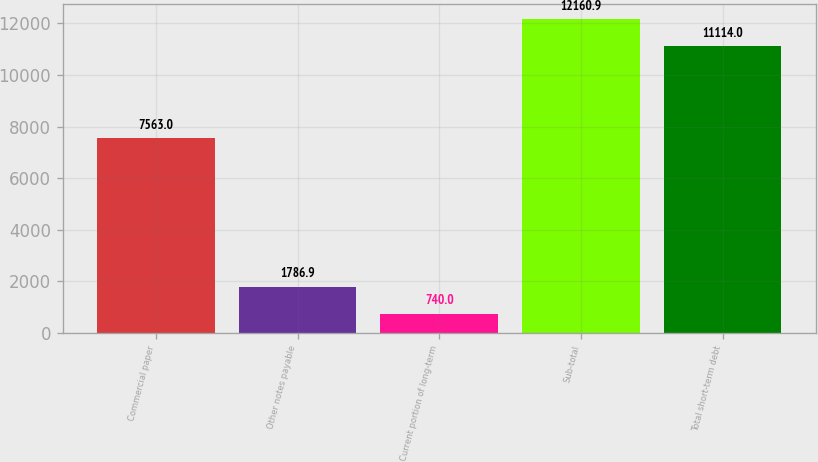<chart> <loc_0><loc_0><loc_500><loc_500><bar_chart><fcel>Commercial paper<fcel>Other notes payable<fcel>Current portion of long-term<fcel>Sub-total<fcel>Total short-term debt<nl><fcel>7563<fcel>1786.9<fcel>740<fcel>12160.9<fcel>11114<nl></chart> 